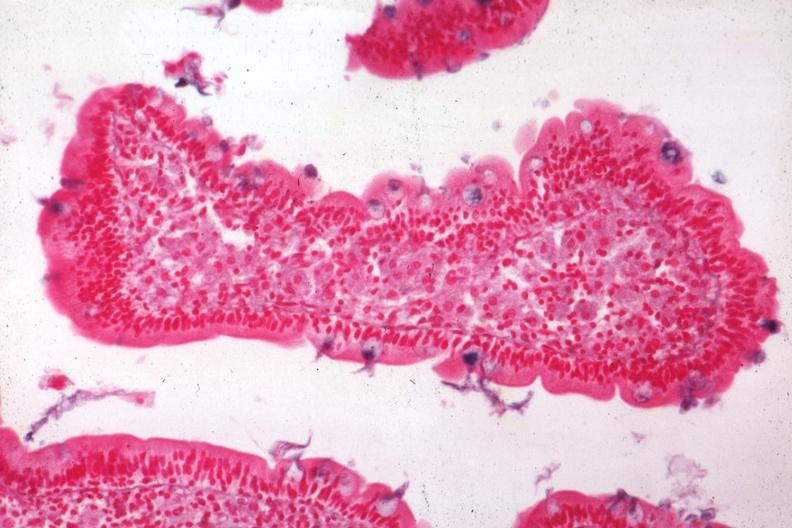does normal ovary show med alcian blue with apparently eosin counterstain enlarged villus with many macrophages source?
Answer the question using a single word or phrase. No 